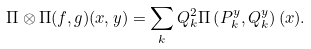<formula> <loc_0><loc_0><loc_500><loc_500>\Pi \otimes \Pi ( f , g ) ( x , y ) = \sum _ { k } Q _ { k } ^ { 2 } \Pi \left ( P _ { k } ^ { y } , Q _ { k } ^ { y } \right ) ( x ) .</formula> 